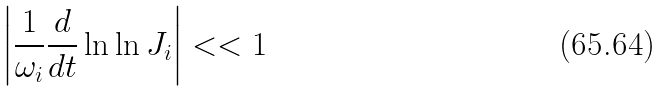<formula> <loc_0><loc_0><loc_500><loc_500>\left | \frac { 1 } { \omega _ { i } } \frac { d } { d t } \ln \ln J _ { i } \right | < < 1</formula> 